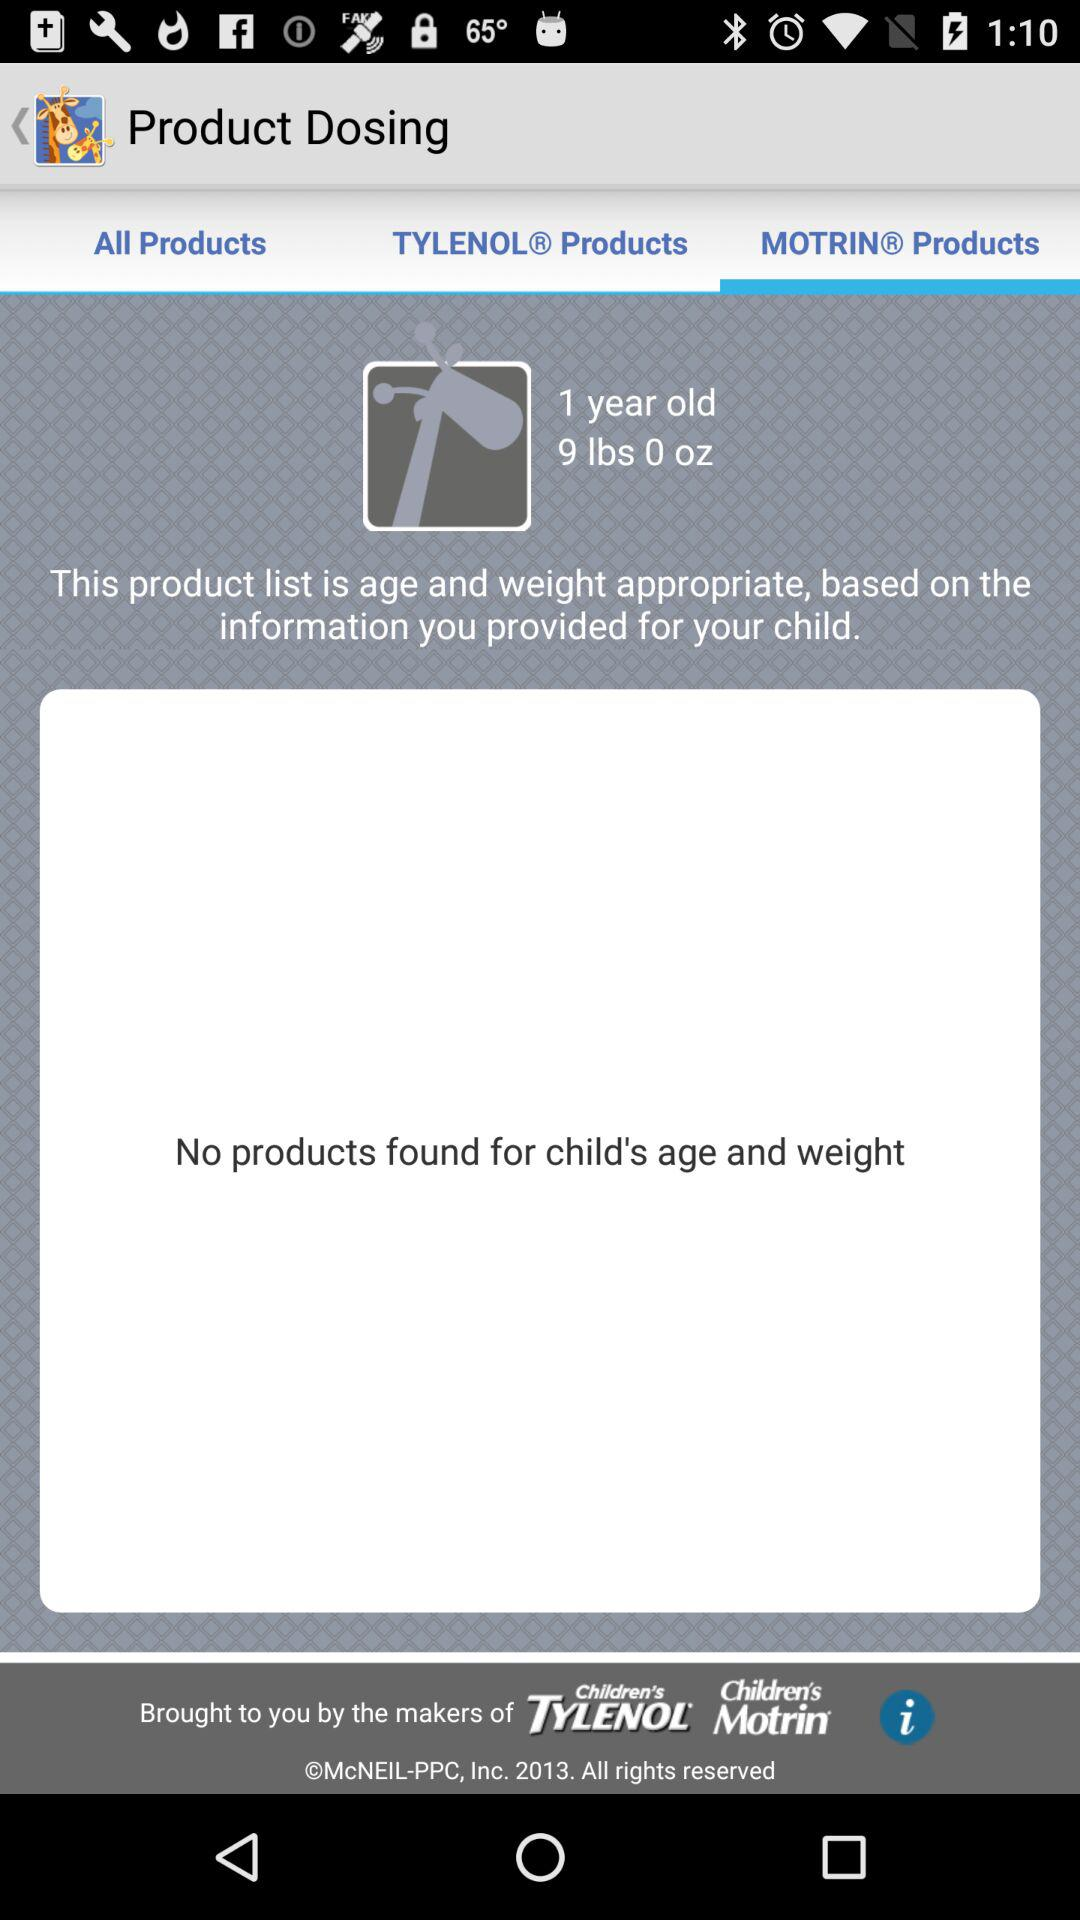What is the name of the application? The name of the application is "Kids' Wellness Tracker". 